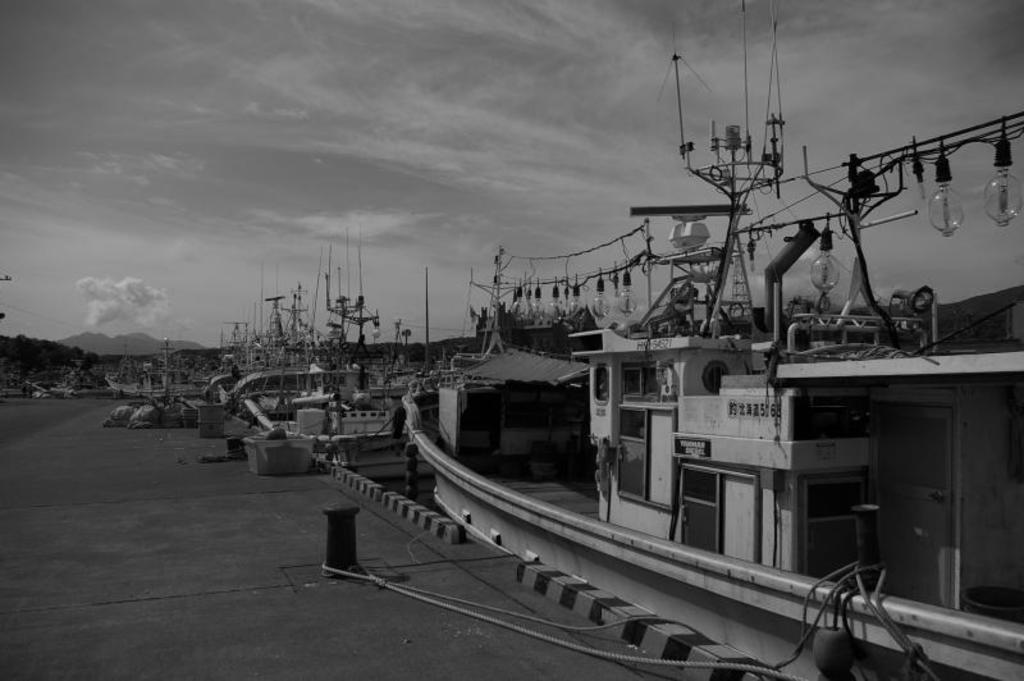What type of vehicles can be seen in the image? There are boats in the image. What structures are present in the image? There are poles in the image. What are the ropes used for in the image? The ropes are likely used for tying or securing the boats. What else can be seen on the ground in the image? There are other objects on the ground, but their specific nature is not mentioned in the facts. What can be seen in the background of the image? The sky, mountains, and possibly other landscape features are visible in the background of the image. How many ducks are swimming in the water near the boats in the image? There are no ducks present in the image; it only features boats, poles, ropes, and other objects on the ground. 